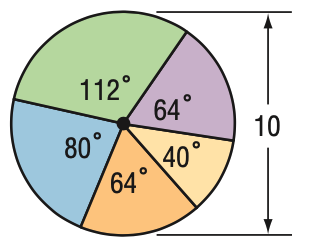Answer the mathemtical geometry problem and directly provide the correct option letter.
Question: Find the area of the blue region.
Choices: A: 8.7 B: 14.0 C: 17.5 D: 24.4 C 